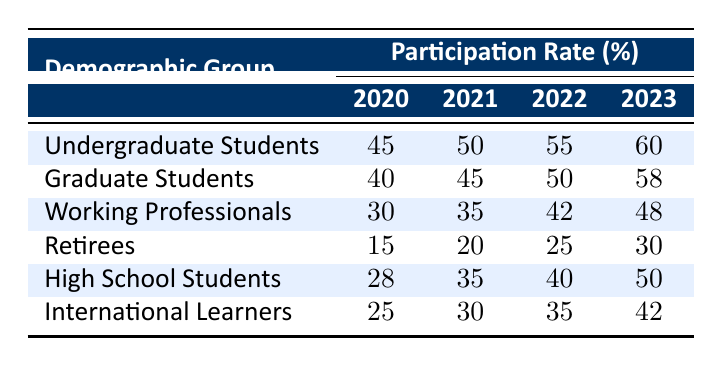What was the participation rate of graduate students in 2022? The table shows a specific value for the participation rate of graduate students in the year 2022. It states that the participation rate was 50%.
Answer: 50 Which demographic group had the highest participation rate in 2023? By examining the participation rates for each demographic group in 2023, we find that undergraduate students had the highest rate at 60%.
Answer: 60 How much did the participation of working professionals increase from 2020 to 2023? To find the increase, we need to subtract the participation rate in 2020 (30%) from that in 2023 (48%). The calculation gives us 48% - 30% = 18%.
Answer: 18 Did retirees experience a participation rate above 25% in 2022? Referring to the table for retirees, their participation rate in 2022 is listed as 25%, which is not above 25%. Therefore, the answer is no.
Answer: No What is the average participation rate for high school students across the years? To find the average, we sum the participation rates for high school students from 2020 to 2023: 28 + 35 + 40 + 50 = 153. Then, we divide by the number of years, which is 4, resulting in an average of 153 / 4 = 38.25.
Answer: 38.25 Which demographic group saw the smallest increase in participation rates from 2020 to 2023? We calculate the increases for each group by subtracting the 2020 rates from the 2023 rates. The smallest increase is for retirees: 30% - 15% = 15%.
Answer: Retirees Was the participation rate of international learners consistently less than 50% from 2020 to 2023? Looking at the data, the rates were 25%, 30%, 35%, and 42% for the respective years, which are all below 50%. Therefore, the answer to this question is yes.
Answer: Yes What is the difference in participation rate between undergraduate and graduate students in 2021? By checking the rates for undergraduate students (50%) and graduate students (45%) in 2021, we find the difference is 50% - 45% = 5%.
Answer: 5 In which year did high school students achieve a participation rate of 40%? The table indicates that high school students reached a participation rate of 40% in 2022.
Answer: 2022 